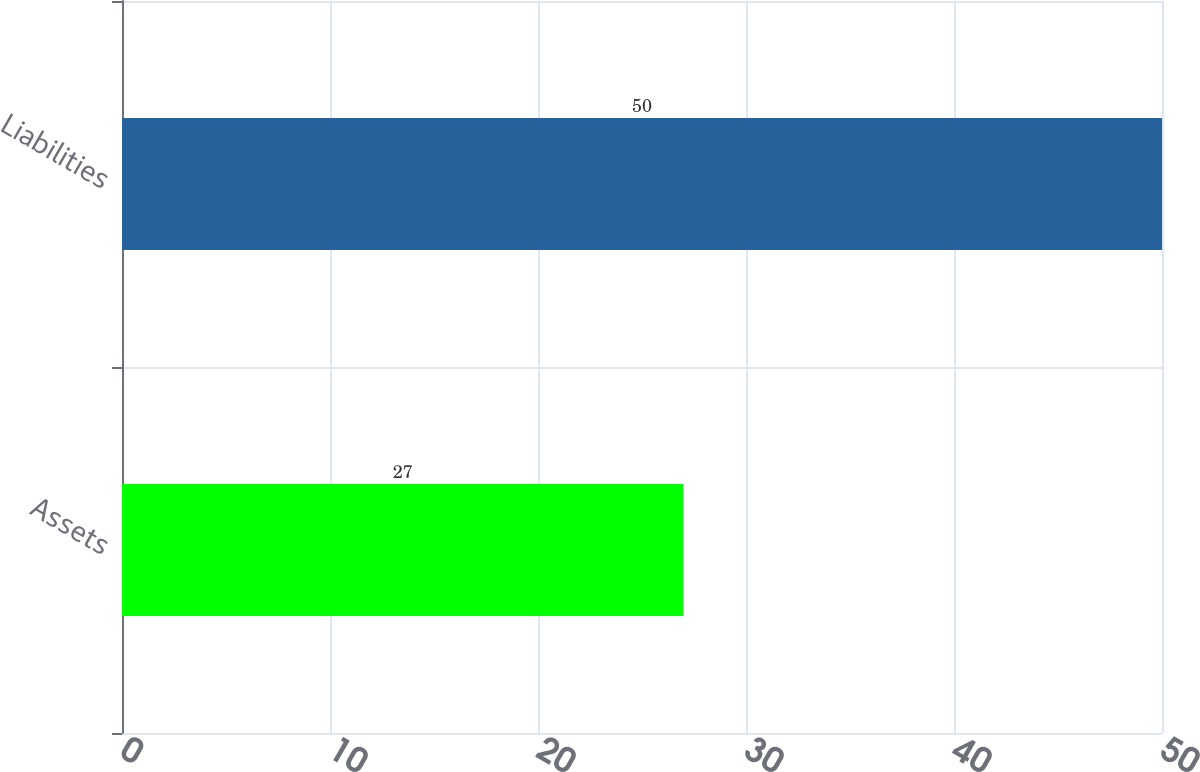Convert chart to OTSL. <chart><loc_0><loc_0><loc_500><loc_500><bar_chart><fcel>Assets<fcel>Liabilities<nl><fcel>27<fcel>50<nl></chart> 